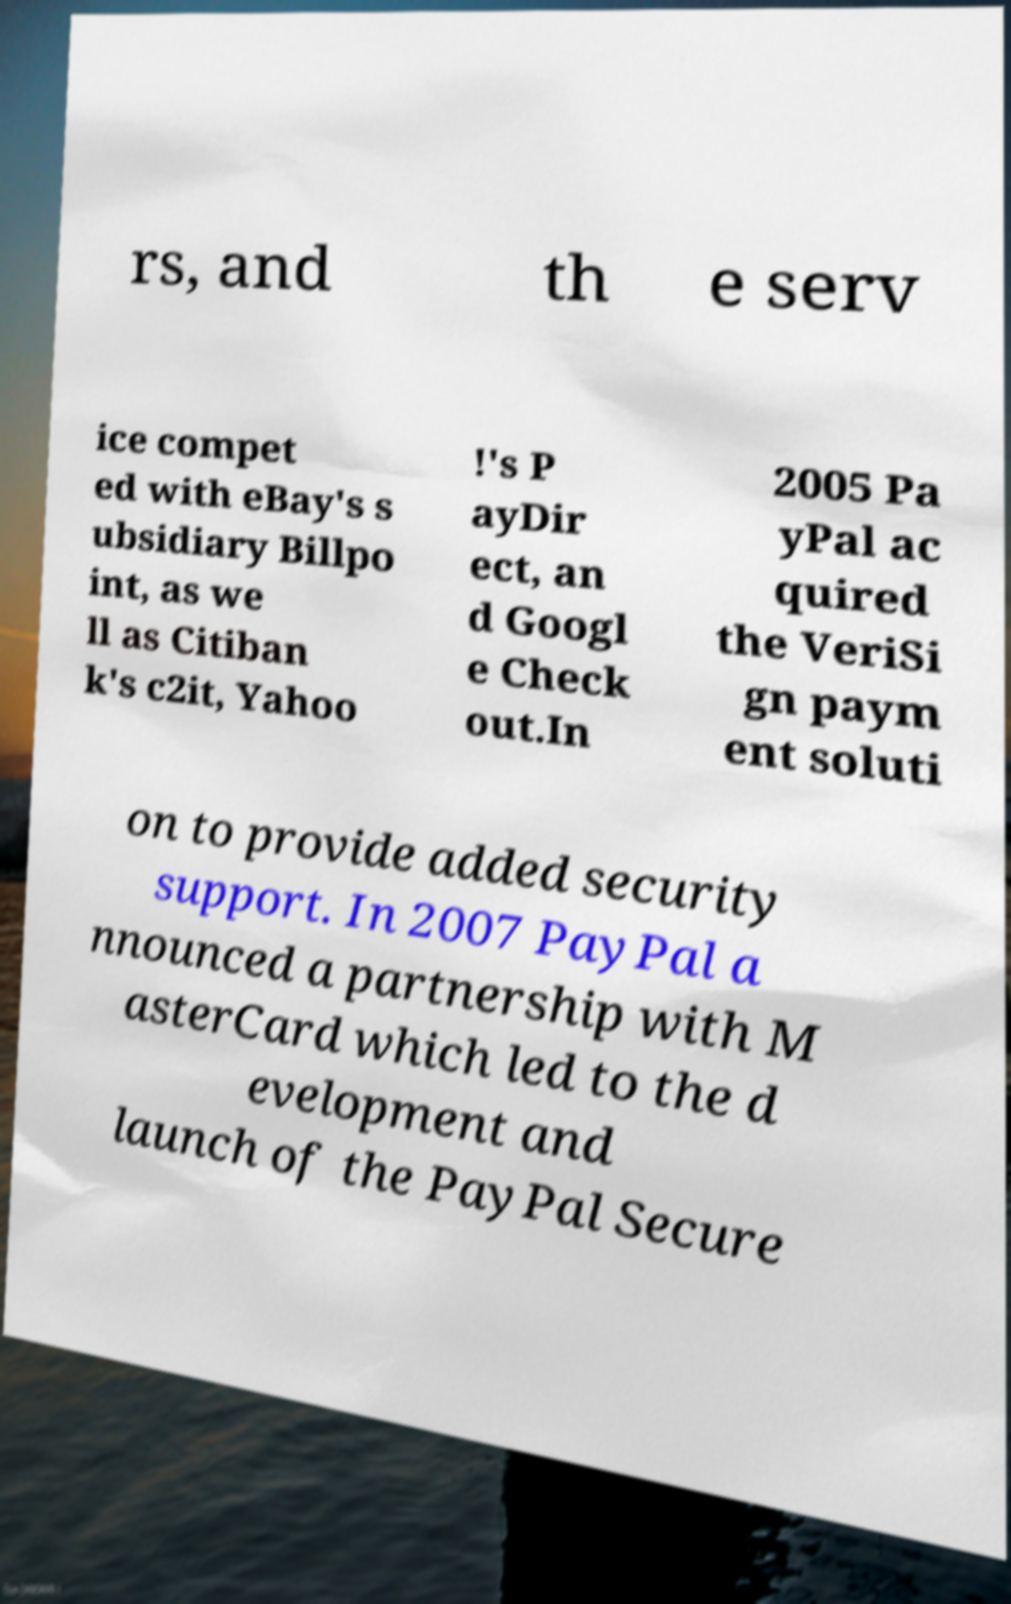Could you extract and type out the text from this image? rs, and th e serv ice compet ed with eBay's s ubsidiary Billpo int, as we ll as Citiban k's c2it, Yahoo !'s P ayDir ect, an d Googl e Check out.In 2005 Pa yPal ac quired the VeriSi gn paym ent soluti on to provide added security support. In 2007 PayPal a nnounced a partnership with M asterCard which led to the d evelopment and launch of the PayPal Secure 